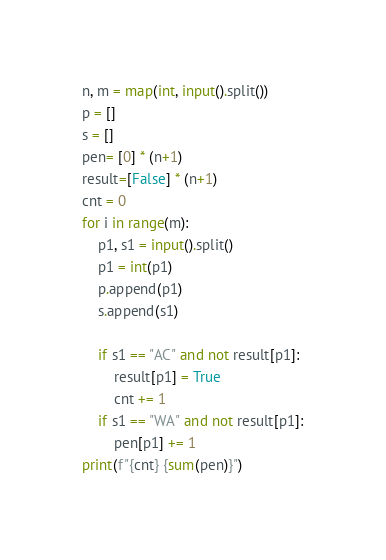Convert code to text. <code><loc_0><loc_0><loc_500><loc_500><_Python_>n, m = map(int, input().split())
p = []
s = []
pen= [0] * (n+1)
result=[False] * (n+1)
cnt = 0
for i in range(m):
    p1, s1 = input().split()
    p1 = int(p1)
    p.append(p1)
    s.append(s1)

    if s1 == "AC" and not result[p1]:
        result[p1] = True
        cnt += 1
    if s1 == "WA" and not result[p1]:
        pen[p1] += 1
print(f"{cnt} {sum(pen)}")
</code> 